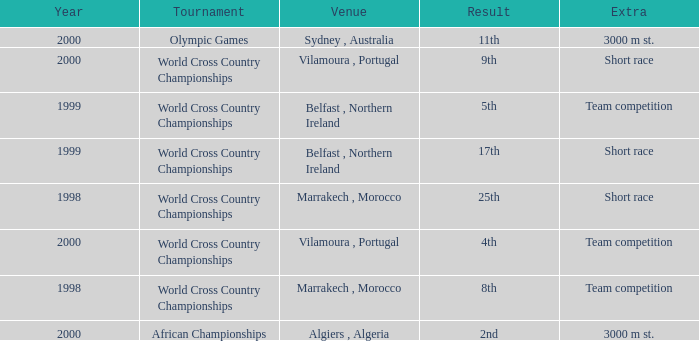Tell me the venue for extra of short race and year less than 1999 Marrakech , Morocco. Would you mind parsing the complete table? {'header': ['Year', 'Tournament', 'Venue', 'Result', 'Extra'], 'rows': [['2000', 'Olympic Games', 'Sydney , Australia', '11th', '3000 m st.'], ['2000', 'World Cross Country Championships', 'Vilamoura , Portugal', '9th', 'Short race'], ['1999', 'World Cross Country Championships', 'Belfast , Northern Ireland', '5th', 'Team competition'], ['1999', 'World Cross Country Championships', 'Belfast , Northern Ireland', '17th', 'Short race'], ['1998', 'World Cross Country Championships', 'Marrakech , Morocco', '25th', 'Short race'], ['2000', 'World Cross Country Championships', 'Vilamoura , Portugal', '4th', 'Team competition'], ['1998', 'World Cross Country Championships', 'Marrakech , Morocco', '8th', 'Team competition'], ['2000', 'African Championships', 'Algiers , Algeria', '2nd', '3000 m st.']]} 